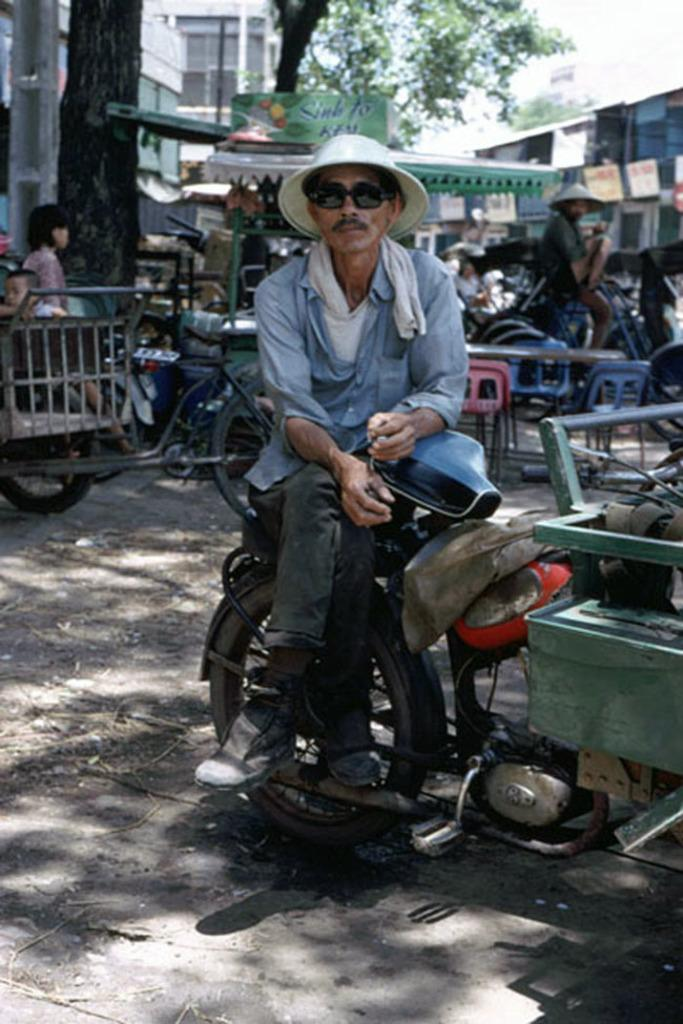What is the person in the image wearing on their head? The person in the image is wearing a hat. What is the person doing while wearing the hat? The person is sitting on a bike. How many people are in the image? There are people in the image. What are the people sitting on? There are bikes in the image. What type of vegetation can be seen in the image? There are trees in the image. What type of structures are visible in the image? There are buildings in the image. What is the amusement park's name in the image? There is no amusement park mentioned or visible in the image. What is the taste of the hat in the image? Hats do not have a taste, as they are not edible. 